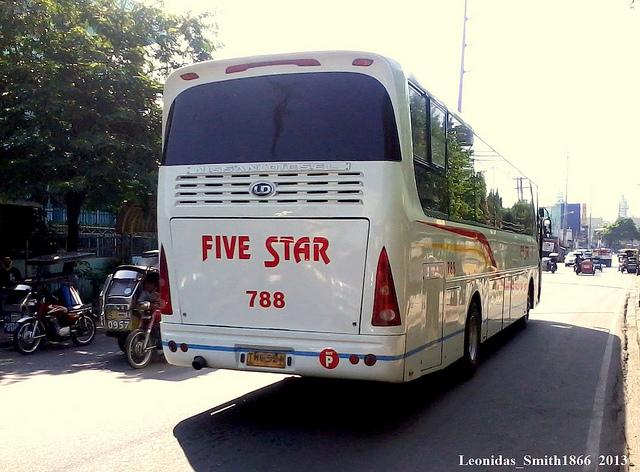What kind of vehicle is this?
Be succinct. Bus. What are the numbers in red?
Keep it brief. 788. What numbers are in red?
Answer briefly. 788. 